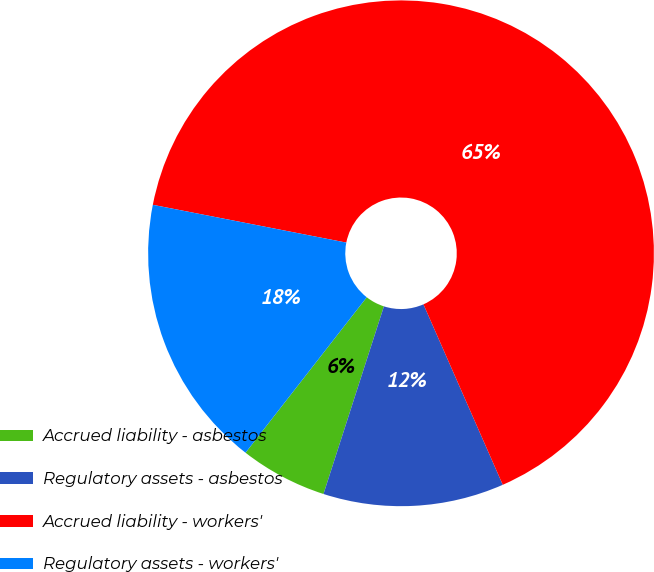Convert chart. <chart><loc_0><loc_0><loc_500><loc_500><pie_chart><fcel>Accrued liability - asbestos<fcel>Regulatory assets - asbestos<fcel>Accrued liability - workers'<fcel>Regulatory assets - workers'<nl><fcel>5.58%<fcel>11.55%<fcel>65.34%<fcel>17.53%<nl></chart> 